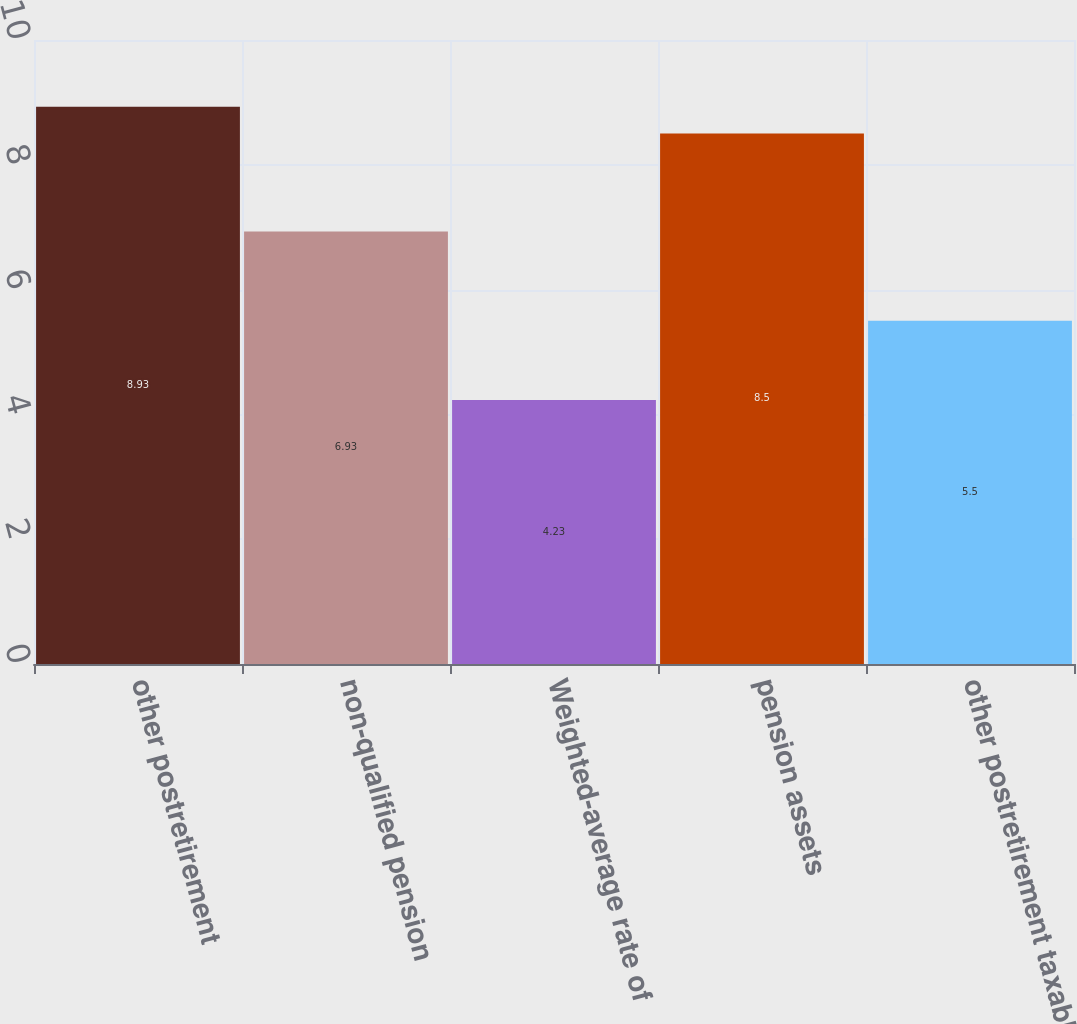Convert chart. <chart><loc_0><loc_0><loc_500><loc_500><bar_chart><fcel>other postretirement<fcel>non-qualified pension<fcel>Weighted-average rate of<fcel>pension assets<fcel>other postretirement taxable<nl><fcel>8.93<fcel>6.93<fcel>4.23<fcel>8.5<fcel>5.5<nl></chart> 